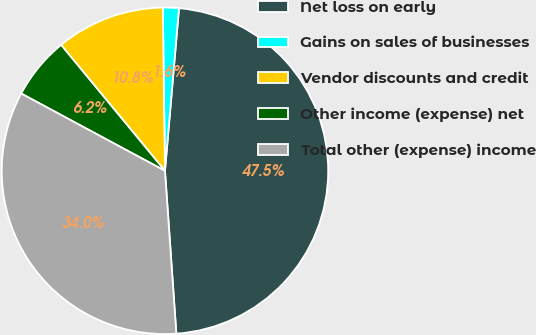<chart> <loc_0><loc_0><loc_500><loc_500><pie_chart><fcel>Net loss on early<fcel>Gains on sales of businesses<fcel>Vendor discounts and credit<fcel>Other income (expense) net<fcel>Total other (expense) income<nl><fcel>47.52%<fcel>1.58%<fcel>10.77%<fcel>6.17%<fcel>33.96%<nl></chart> 